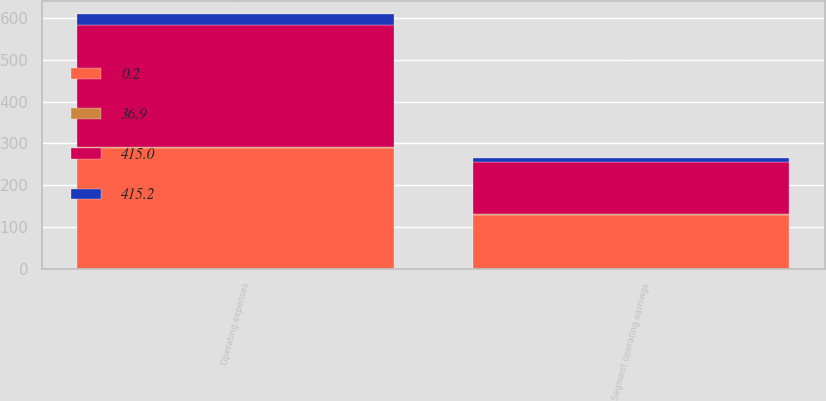Convert chart. <chart><loc_0><loc_0><loc_500><loc_500><stacked_bar_chart><ecel><fcel>Operating expenses<fcel>Segment operating earnings<nl><fcel>0.2<fcel>287.7<fcel>127.3<nl><fcel>415.2<fcel>25.6<fcel>11.3<nl><fcel>415<fcel>291.8<fcel>123.4<nl><fcel>36.9<fcel>4.1<fcel>3.9<nl></chart> 